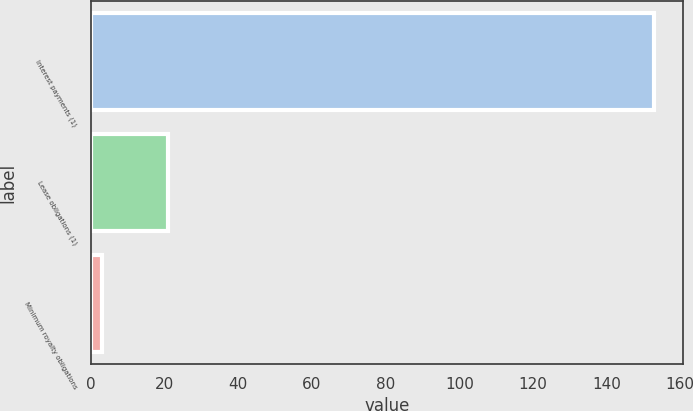<chart> <loc_0><loc_0><loc_500><loc_500><bar_chart><fcel>Interest payments (1)<fcel>Lease obligations (1)<fcel>Minimum royalty obligations<nl><fcel>153<fcel>21<fcel>3<nl></chart> 